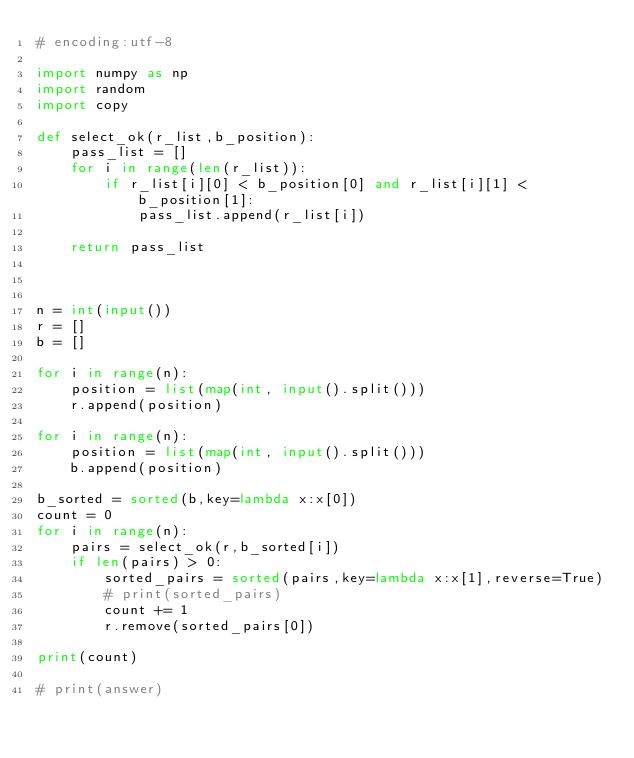<code> <loc_0><loc_0><loc_500><loc_500><_Python_># encoding:utf-8

import numpy as np
import random
import copy

def select_ok(r_list,b_position):
    pass_list = []
    for i in range(len(r_list)):
        if r_list[i][0] < b_position[0] and r_list[i][1] < b_position[1]:
            pass_list.append(r_list[i])

    return pass_list



n = int(input())
r = []
b = []

for i in range(n):
    position = list(map(int, input().split()))
    r.append(position)

for i in range(n):
    position = list(map(int, input().split()))
    b.append(position)

b_sorted = sorted(b,key=lambda x:x[0])
count = 0
for i in range(n):
    pairs = select_ok(r,b_sorted[i])
    if len(pairs) > 0:
        sorted_pairs = sorted(pairs,key=lambda x:x[1],reverse=True)
        # print(sorted_pairs)
        count += 1
        r.remove(sorted_pairs[0])

print(count)

# print(answer)
</code> 